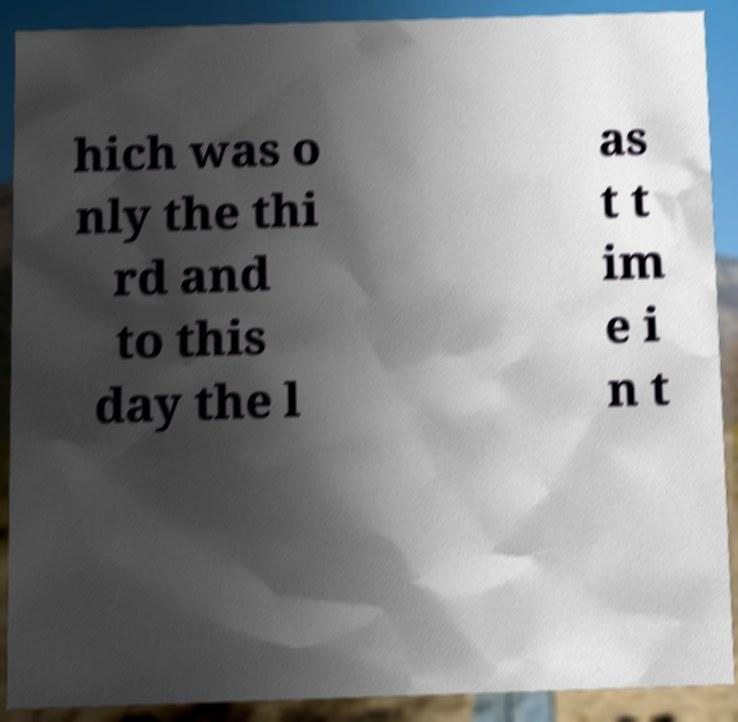Can you accurately transcribe the text from the provided image for me? hich was o nly the thi rd and to this day the l as t t im e i n t 